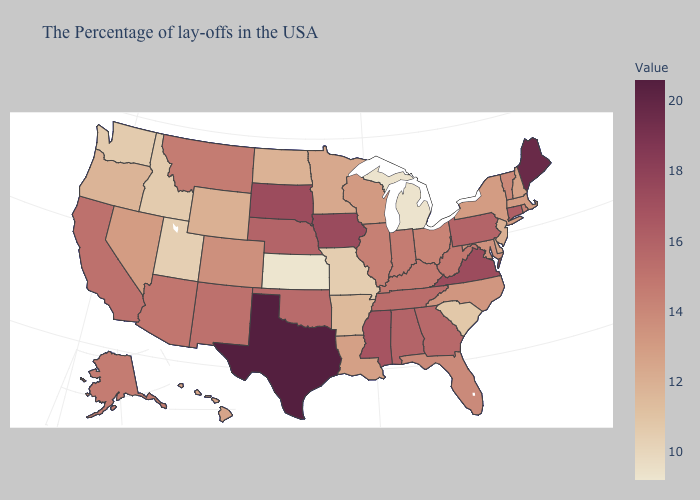Which states have the highest value in the USA?
Concise answer only. Texas. Is the legend a continuous bar?
Give a very brief answer. Yes. Among the states that border West Virginia , does Virginia have the lowest value?
Write a very short answer. No. Among the states that border Virginia , which have the highest value?
Keep it brief. Tennessee. Which states have the lowest value in the MidWest?
Be succinct. Kansas. Among the states that border North Carolina , which have the highest value?
Concise answer only. Virginia. 